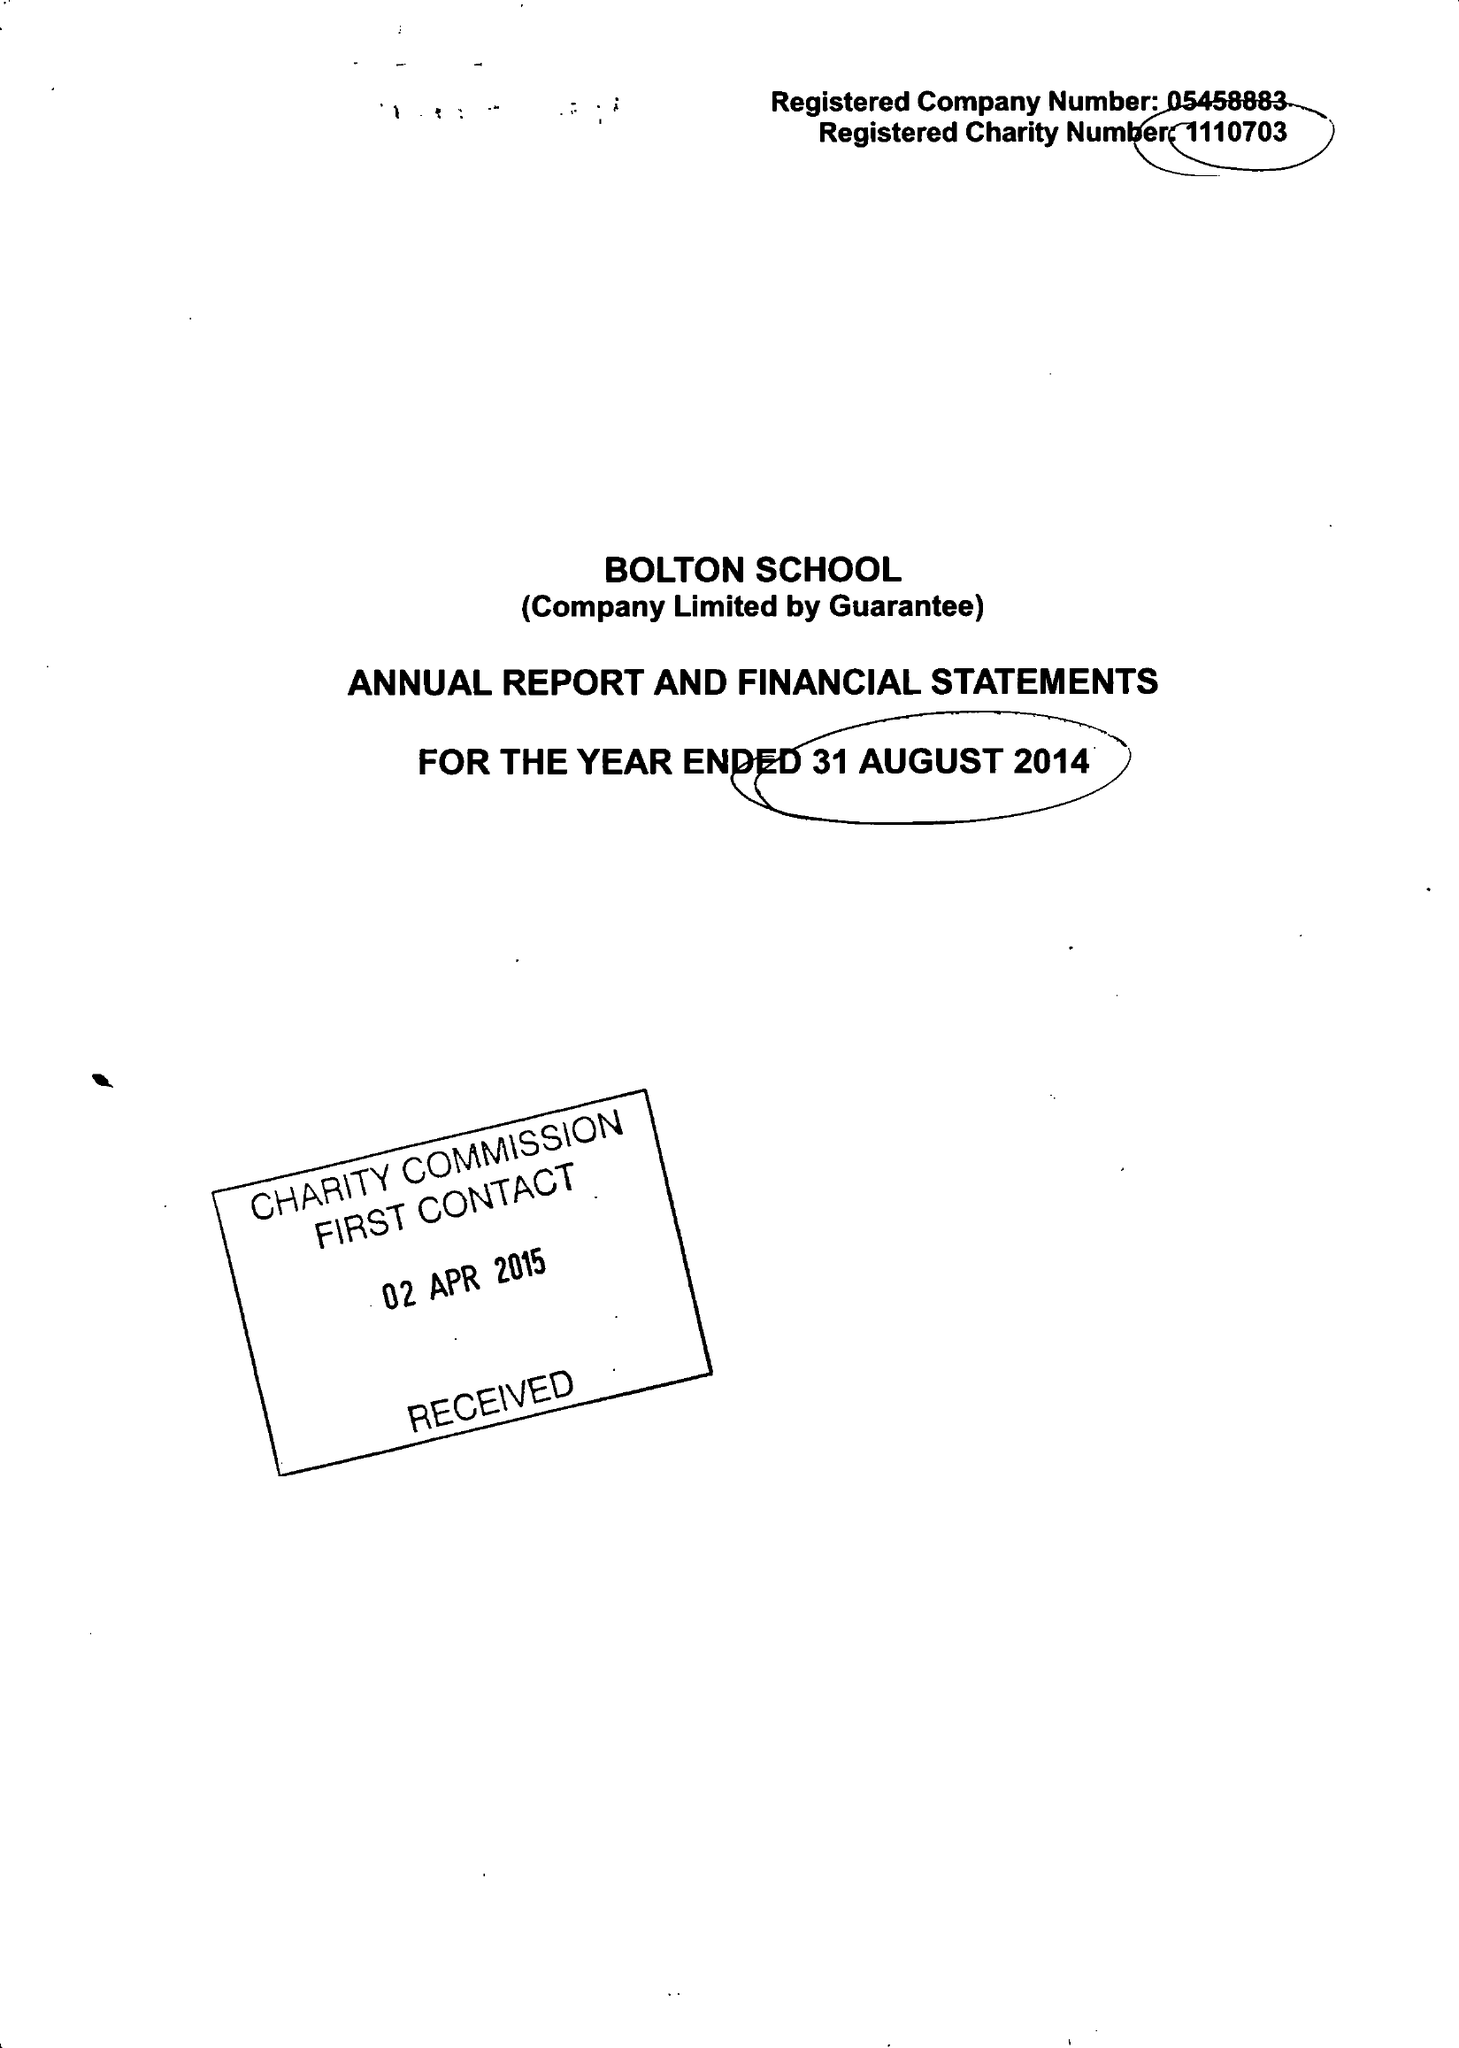What is the value for the address__street_line?
Answer the question using a single word or phrase. CHORLEY NEW ROAD 